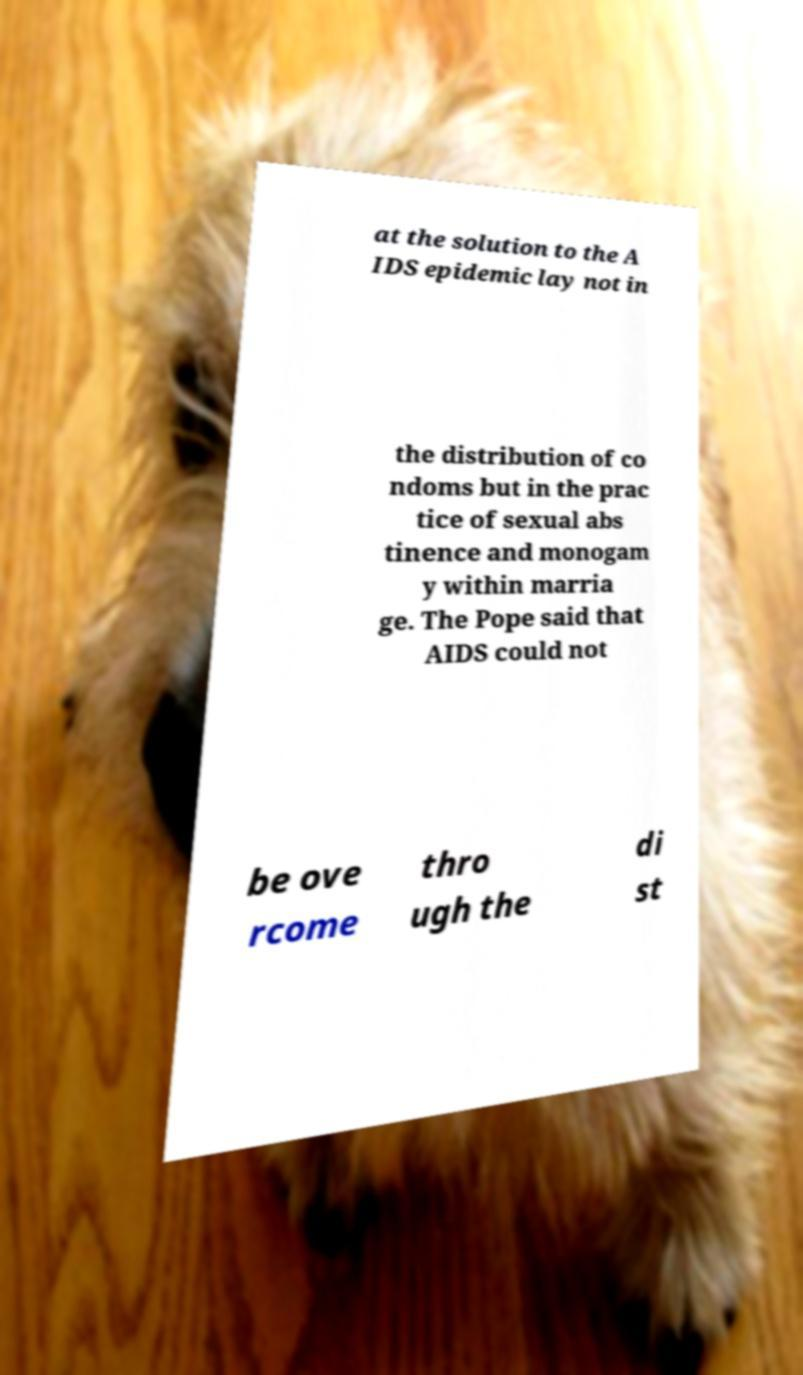Could you extract and type out the text from this image? at the solution to the A IDS epidemic lay not in the distribution of co ndoms but in the prac tice of sexual abs tinence and monogam y within marria ge. The Pope said that AIDS could not be ove rcome thro ugh the di st 